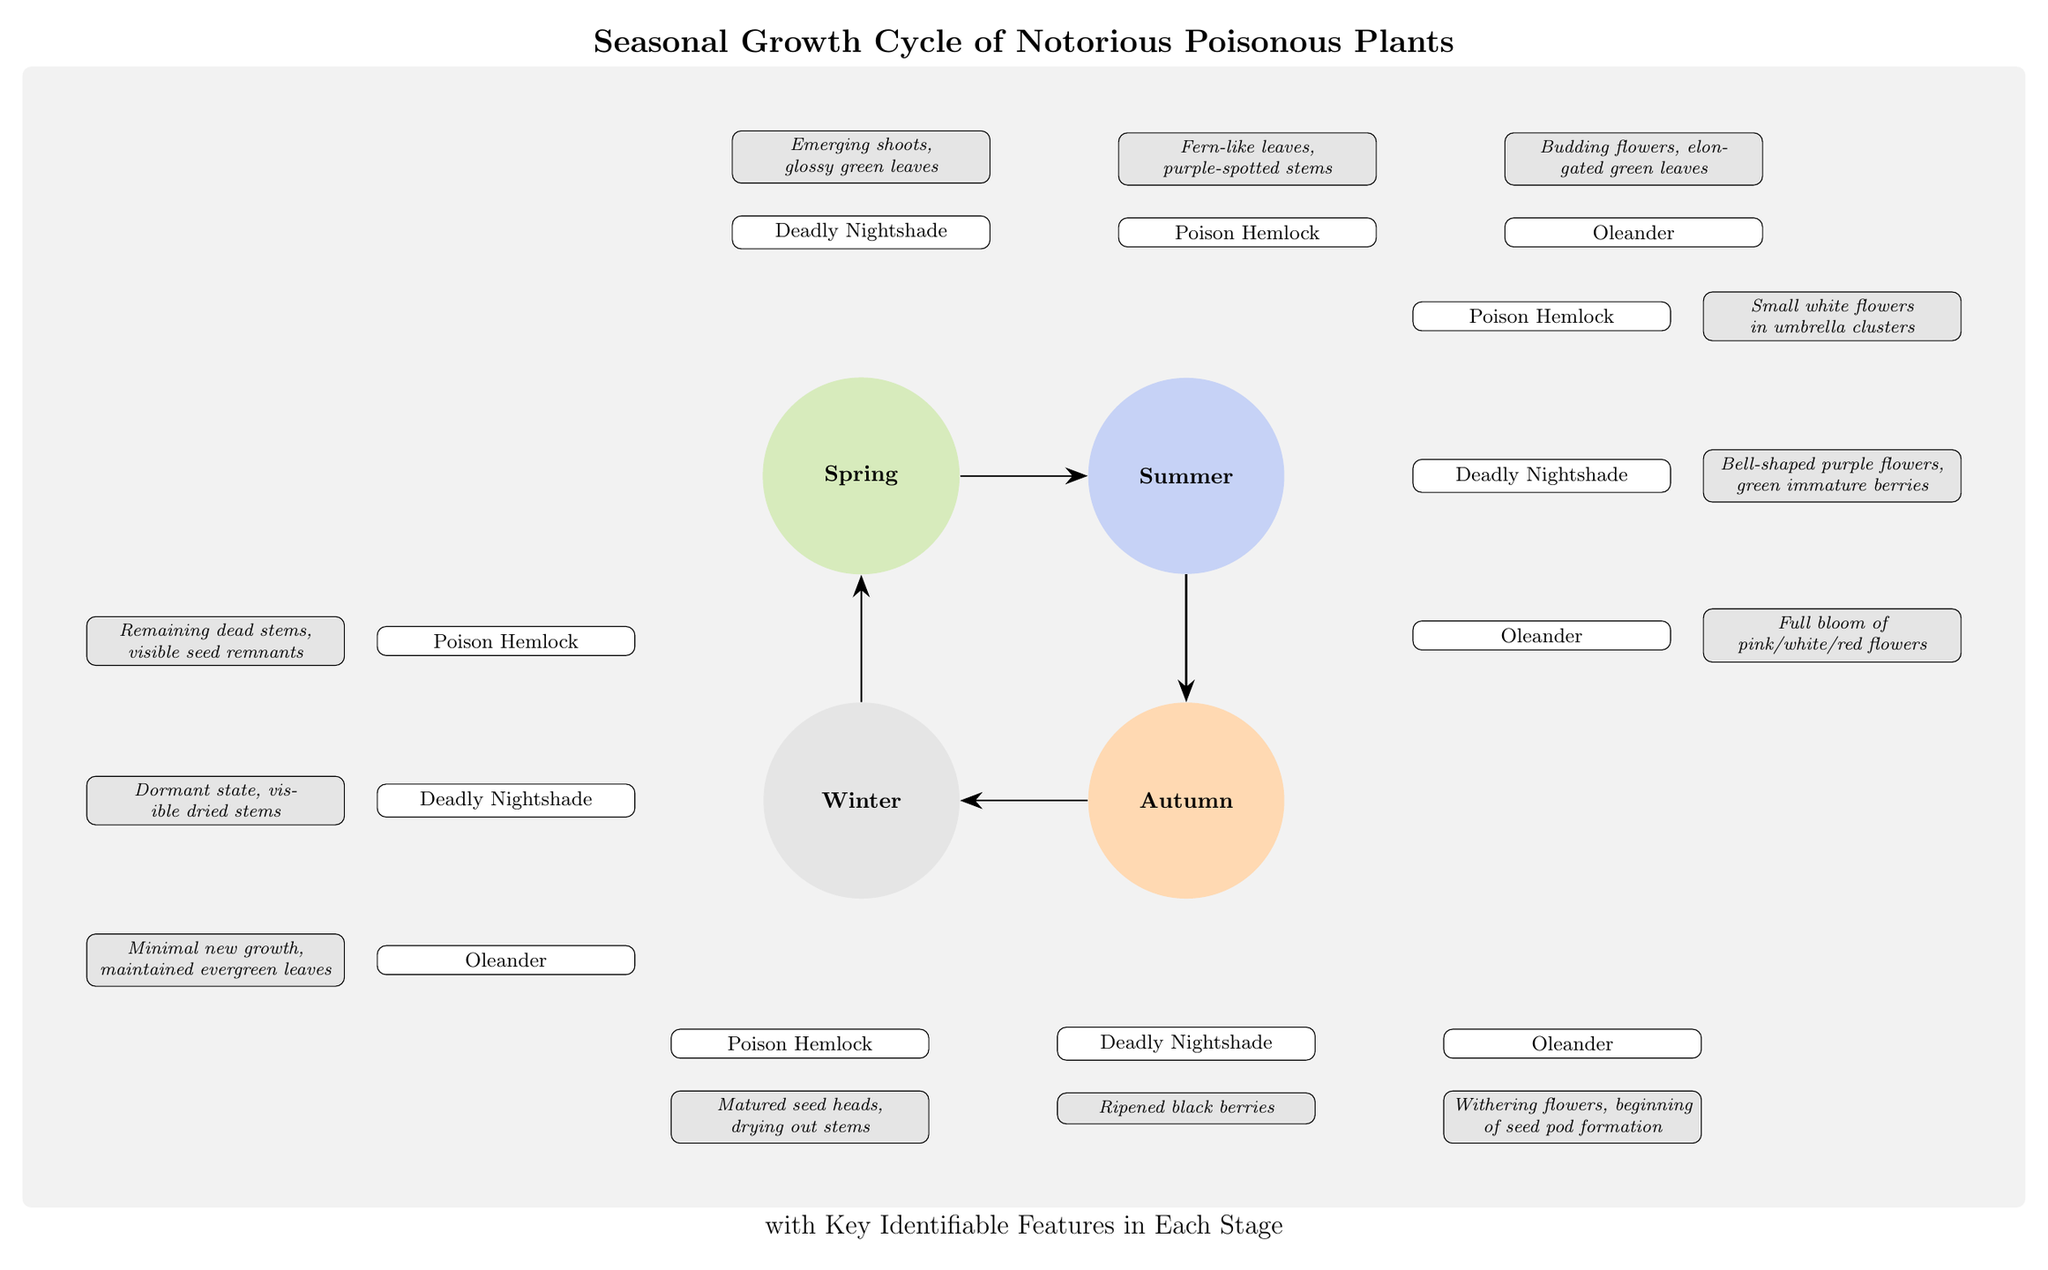What are the identifiable features of the Deadly Nightshade in Spring? In the Spring section, the Deadly Nightshade is associated with the feature described as "Emerging shoots, glossy green leaves." This information is specifically stated in the diagram directly above the Deadly Nightshade for Spring.
Answer: Emerging shoots, glossy green leaves How many poisonous plants are depicted in the Summer section? In the Summer section, there are three poisonous plants listed: Deadly Nightshade, Poison Hemlock, and Oleander. By counting the plants directly within the Summer node, we find three.
Answer: 3 What is the identifiable feature of Poison Hemlock in Autumn? In the Autumn section, Poison Hemlock is identified with the feature "Matured seed heads, drying out stems." This is mentioned in the graphical representation just below the Poison Hemlock node in Autumn.
Answer: Matured seed heads, drying out stems Which plant has ripened black berries in Autumn? The plant with "Ripened black berries" in Autumn is Deadly Nightshade. This can be identified directly beneath the Autumn node in the diagram.
Answer: Deadly Nightshade What seasonal feature is shared by Oleander during Summer and Winter? In both summer and winter, Oleander is consistently mentioned with features that denote its flowering and growth state. In Summer it shows "Full bloom of pink/white/red flowers" while in Winter, "Minimal new growth, maintained evergreen leaves" indicates stability across seasons. The feature indicates minimal change between these two seasons.
Answer: Flowering and evergreen leaves What is the relationship between Winter and Spring in the seasonal cycle? The relationship is a cyclical one, with an arrow indicating that after Winter comes Spring. This is clearly marked in the directionality of the arrows drawn between the seasons, indicating the flow of the seasonal growth cycle.
Answer: Cyclical relationship What color are the flowers of Poison Hemlock in Summer? In the Summer section, Poison Hemlock features "Small white flowers in umbrella clusters." This distinct characteristic is specifically noted in the diagram for the plant during Summer.
Answer: Small white flowers How many identifiable features are listed for Oleander? For Oleander, there are three identifiable features listed across the seasons: beginning with budding flowers in Spring, full bloom in Summer, and withering flowers in Autumn, followed by minimal new growth in Winter. This provides a total of four identifiable features through its growth stages.
Answer: 4 